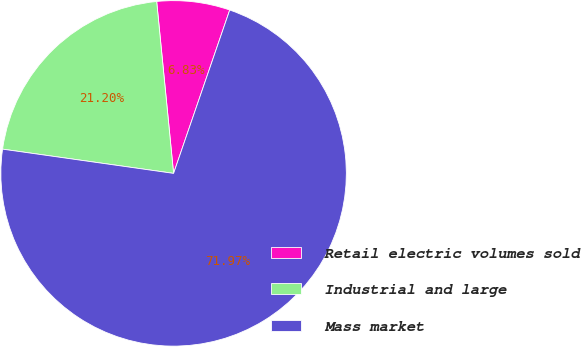Convert chart. <chart><loc_0><loc_0><loc_500><loc_500><pie_chart><fcel>Retail electric volumes sold<fcel>Industrial and large<fcel>Mass market<nl><fcel>6.83%<fcel>21.2%<fcel>71.98%<nl></chart> 